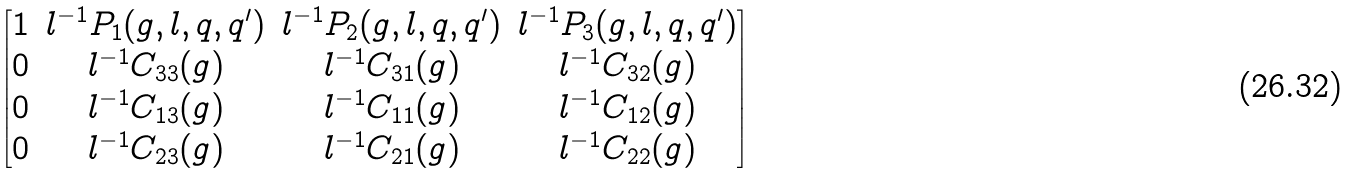<formula> <loc_0><loc_0><loc_500><loc_500>\begin{bmatrix} 1 & l ^ { - 1 } P _ { 1 } ( g , l , q , q ^ { \prime } ) & l ^ { - 1 } P _ { 2 } ( g , l , q , q ^ { \prime } ) & l ^ { - 1 } P _ { 3 } ( g , l , q , q ^ { \prime } ) \\ 0 & l ^ { - 1 } C _ { 3 3 } ( g ) & l ^ { - 1 } C _ { 3 1 } ( g ) & l ^ { - 1 } C _ { 3 2 } ( g ) \\ 0 & l ^ { - 1 } C _ { 1 3 } ( g ) & l ^ { - 1 } C _ { 1 1 } ( g ) & l ^ { - 1 } C _ { 1 2 } ( g ) \\ 0 & l ^ { - 1 } C _ { 2 3 } ( g ) & l ^ { - 1 } C _ { 2 1 } ( g ) & l ^ { - 1 } C _ { 2 2 } ( g ) \end{bmatrix}</formula> 